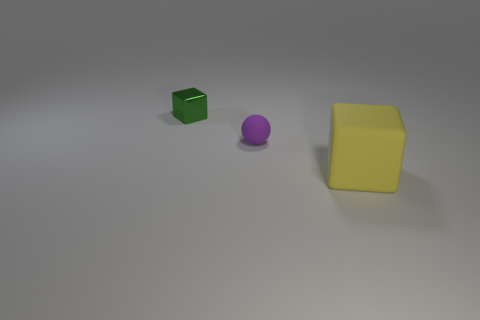How many things are either small green objects or cyan metal cylinders?
Make the answer very short. 1. Do the cube that is behind the yellow cube and the big cube have the same material?
Offer a terse response. No. What is the size of the purple ball?
Offer a terse response. Small. What number of cubes are big yellow objects or tiny shiny objects?
Your answer should be compact. 2. Is the number of tiny green cubes that are to the right of the big cube the same as the number of cubes that are in front of the tiny metallic block?
Your response must be concise. No. There is another object that is the same shape as the green shiny thing; what size is it?
Your answer should be compact. Large. How big is the thing that is in front of the green object and left of the yellow matte cube?
Your response must be concise. Small. Are there any rubber cubes behind the tiny purple ball?
Ensure brevity in your answer.  No. How many things are either cubes that are in front of the small green shiny block or small matte spheres?
Keep it short and to the point. 2. There is a tiny object that is in front of the green cube; what number of cubes are on the left side of it?
Ensure brevity in your answer.  1. 